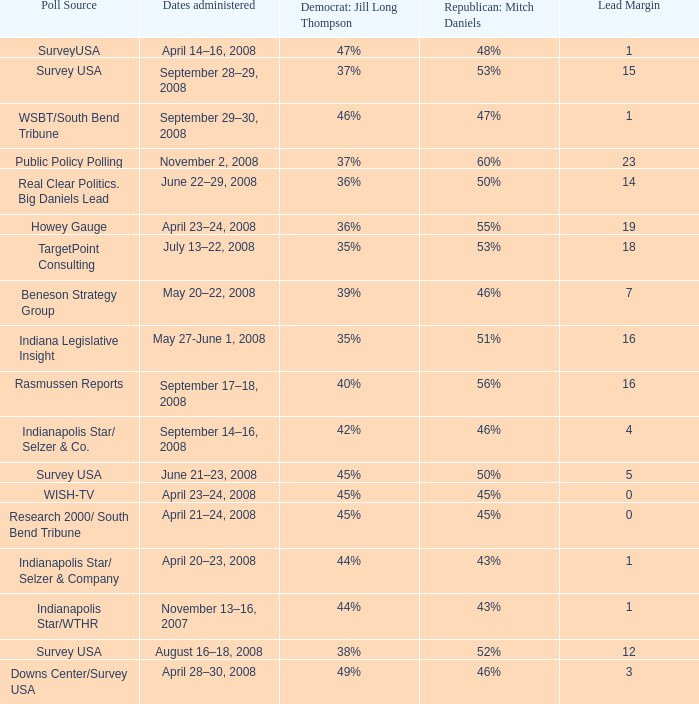What is the lowest Lead Margin when Republican: Mitch Daniels was polling at 48%? 1.0. 